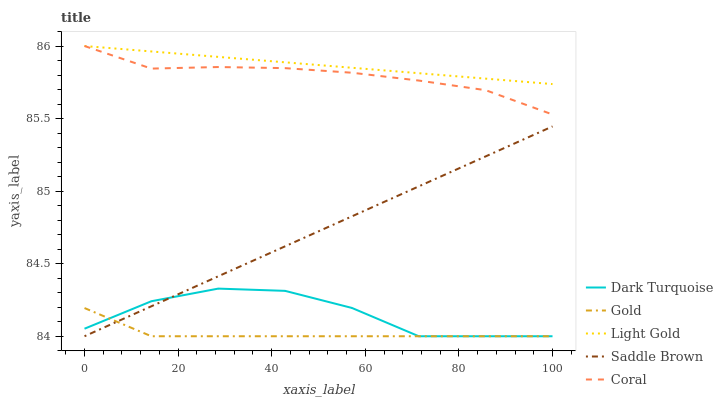Does Gold have the minimum area under the curve?
Answer yes or no. Yes. Does Light Gold have the maximum area under the curve?
Answer yes or no. Yes. Does Coral have the minimum area under the curve?
Answer yes or no. No. Does Coral have the maximum area under the curve?
Answer yes or no. No. Is Light Gold the smoothest?
Answer yes or no. Yes. Is Dark Turquoise the roughest?
Answer yes or no. Yes. Is Coral the smoothest?
Answer yes or no. No. Is Coral the roughest?
Answer yes or no. No. Does Dark Turquoise have the lowest value?
Answer yes or no. Yes. Does Coral have the lowest value?
Answer yes or no. No. Does Light Gold have the highest value?
Answer yes or no. Yes. Does Saddle Brown have the highest value?
Answer yes or no. No. Is Dark Turquoise less than Light Gold?
Answer yes or no. Yes. Is Coral greater than Dark Turquoise?
Answer yes or no. Yes. Does Saddle Brown intersect Dark Turquoise?
Answer yes or no. Yes. Is Saddle Brown less than Dark Turquoise?
Answer yes or no. No. Is Saddle Brown greater than Dark Turquoise?
Answer yes or no. No. Does Dark Turquoise intersect Light Gold?
Answer yes or no. No. 